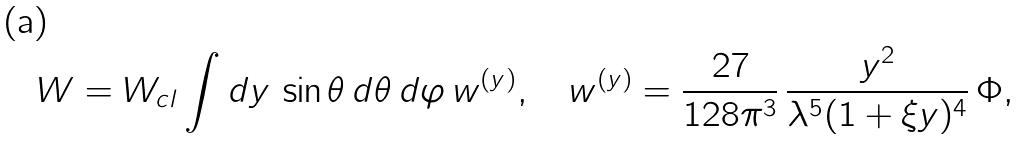Convert formula to latex. <formula><loc_0><loc_0><loc_500><loc_500>W = W _ { c l } \int d y \, \sin \theta \, d \theta \, d \varphi \, w ^ { ( y ) } , \quad w ^ { ( y ) } = \frac { 2 7 } { 1 2 8 \pi ^ { 3 } } \, \frac { y ^ { 2 } } { \lambda ^ { 5 } ( 1 + \xi y ) ^ { 4 } } \, \Phi ,</formula> 